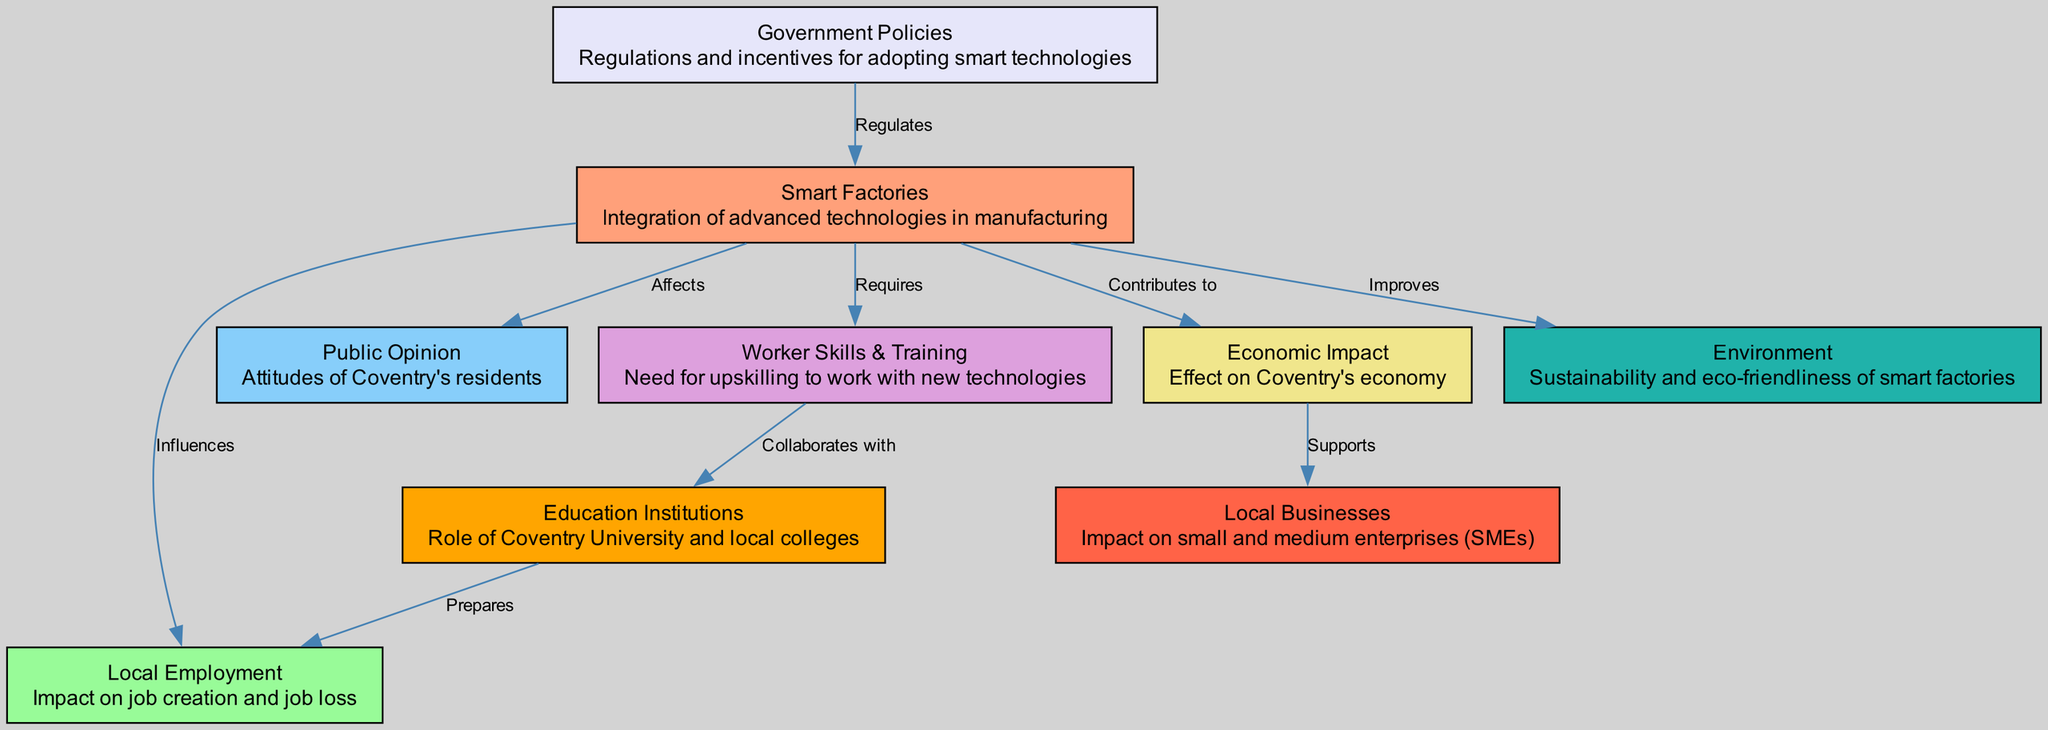What is the total number of nodes in the diagram? The diagram contains 9 distinct nodes representing various elements related to the social perception of smart factories and automation. Each node is identified and labeled, contributing to the overall structure.
Answer: 9 What does "Smart Factories" contribute to? The edge from "Smart Factories" to "Economic Impact" is labeled "Contributes to," indicating that smart factories play a role in improving the economy of Coventry.
Answer: Economic Impact Which node collaborates with "Worker Skills & Training"? The edge from "Worker Skills & Training" to "Education Institutions" is labeled "Collaborates with," indicating that to upskill workers, there is a collaborative relationship with educational entities.
Answer: Education Institutions How many edges are connecting the nodes in the diagram? There are a total of 9 edges depicted in the diagram, illustrating the connections and relationships between various nodes. Each edge represents a directional influence or relationship.
Answer: 9 What is the relationship between "Government Policies" and "Smart Factories"? The edge from "Government Policies" to "Smart Factories" is labeled "Regulates," which indicates that government policies are instrumental in regulating the adoption and operation of smart factories.
Answer: Regulates What role do "Education Institutions" play in relation to "Local Employment"? To answer this, we trace the path: "Education Institutions" prepares the workforce with necessary skills that directly influence "Local Employment" by either creating job opportunities or supporting existing ones through training.
Answer: Prepares How does "Smart Factories" affect "Public Opinion"? The edge connecting "Smart Factories" to "Public Opinion" is labeled "Affects," which signifies that the perceptions of smart factories among the public can change based on their implementation and visible benefits or drawbacks.
Answer: Affects What does "Smart Factories" improve in the local community? The edge from "Smart Factories" to "Environment" is labeled "Improves," which indicates that the integration of smart factory technologies has a favorable impact on sustainability and eco-friendliness in the environment.
Answer: Environment What supports "Local Businesses"? The edge from "Economic Impact" to "Local Businesses" is labeled "Supports," emphasizing that the overall economic influence of smart factories is beneficial to small and medium enterprises in Coventry.
Answer: Economic Impact 